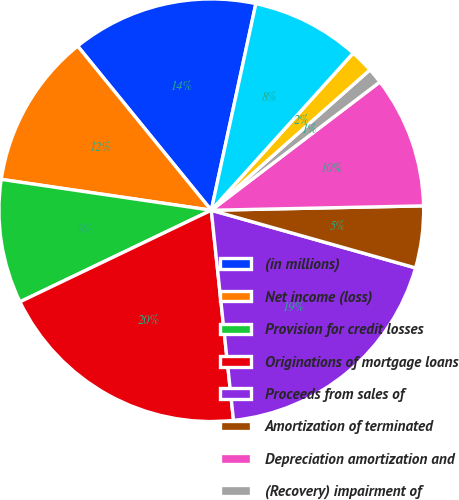Convert chart to OTSL. <chart><loc_0><loc_0><loc_500><loc_500><pie_chart><fcel>(in millions)<fcel>Net income (loss)<fcel>Provision for credit losses<fcel>Originations of mortgage loans<fcel>Proceeds from sales of<fcel>Amortization of terminated<fcel>Depreciation amortization and<fcel>(Recovery) impairment of<fcel>Securities impairment<fcel>Deferred income taxes<nl><fcel>14.2%<fcel>11.83%<fcel>9.47%<fcel>19.53%<fcel>18.93%<fcel>4.73%<fcel>10.06%<fcel>1.18%<fcel>1.78%<fcel>8.28%<nl></chart> 